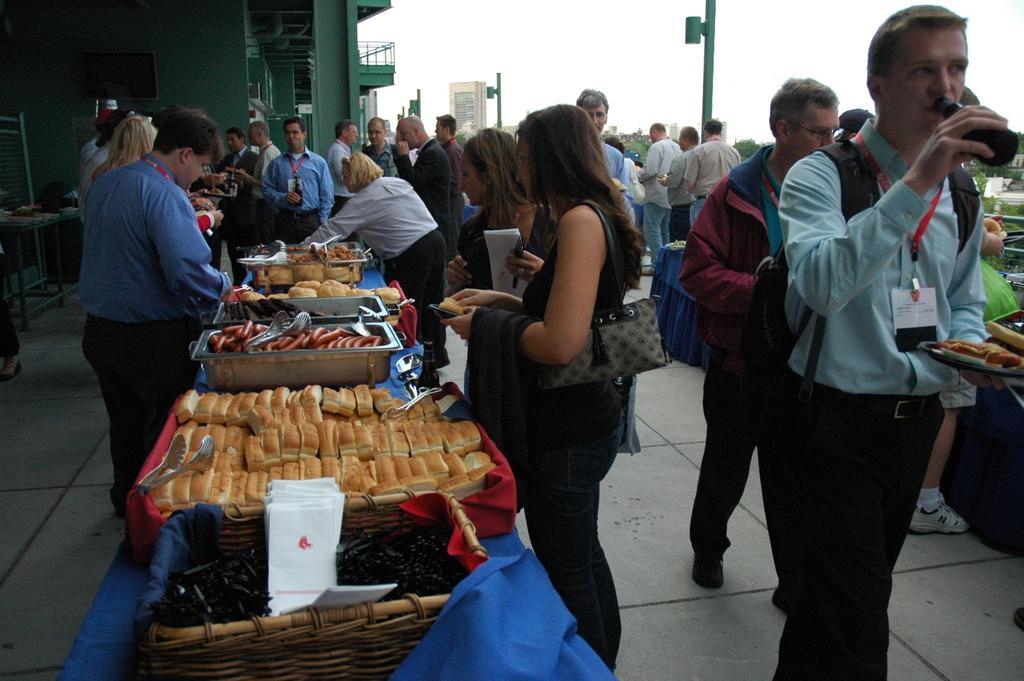How would you summarize this image in a sentence or two? In this image I can see people standing and there are food items in the trays. There is a green building at the back and there are poles and trees at the back. There is sky at the top. 